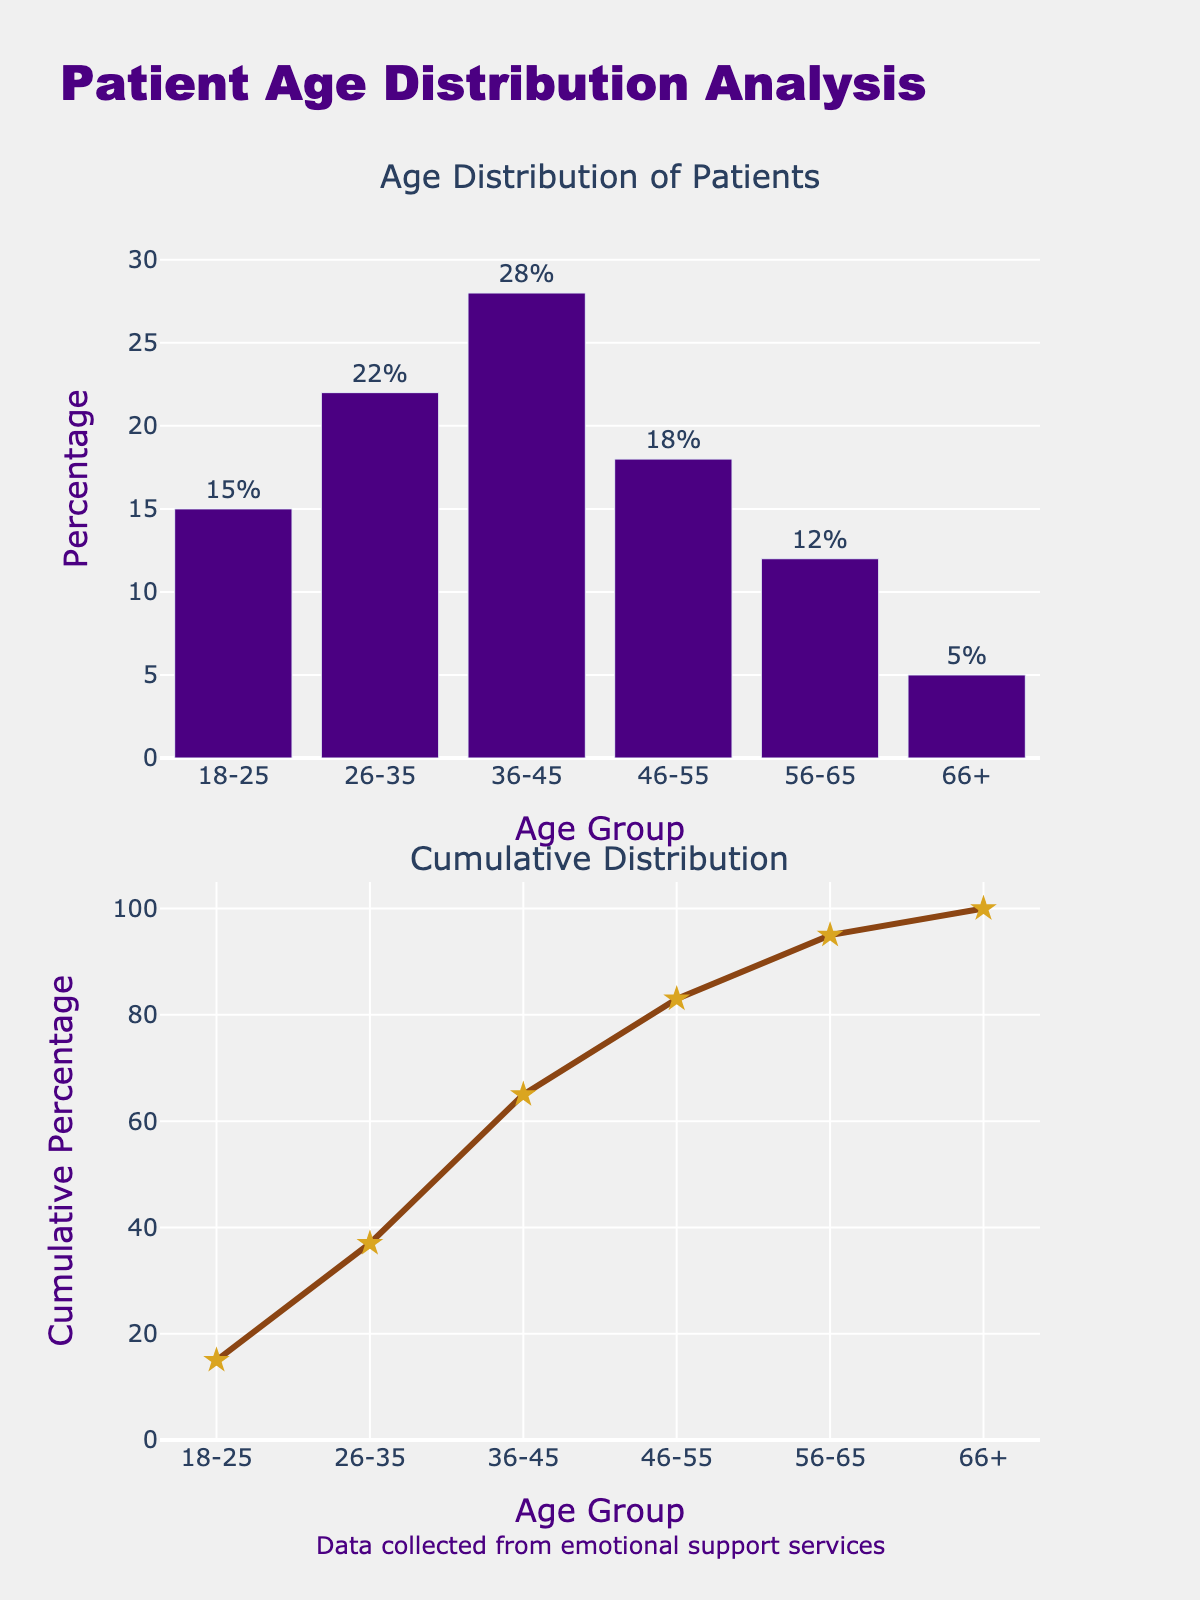What is the title of the figure? The title is written at the top of the figure. It says "Patient Age Distribution Analysis".
Answer: "Patient Age Distribution Analysis" Which age group has the highest percentage of patients? In the first subplot, the bar representing the age group 36-45 is the tallest, indicating it has the highest percentage.
Answer: 36-45 What is the cumulative percentage at the age group 56-65? In the second subplot, follow the line chart to the age group labeled 56-65. The text above the marker reads 95%, which is the cumulative percentage.
Answer: 95% How many age groups are represented in the bar chart? Count the distinct bars in the first subplot. There are six bars, each representing a different age group.
Answer: Six What is the percentage of patients in the age group 26-35? Look at the bar in the first subplot labeled 26-35. The bar's text shows 22%, which represents the percentage.
Answer: 22% By how much does the percentage of the 36-45 age group exceed that of the 18-25 age group? The percentage of the 36-45 age group is 28%, and for the 18-25 age group, it is 15%. Subtracting these gives 28% - 15% = 13%.
Answer: 13% Which age groups together account for over 50% of the patients? Tally the percentages from the first subplot: 18-25 (15%), 26-35 (22%), and 36-45 (28%). These add up to 15% + 22% + 28% = 65%, which is over 50%. Thus, these three groups together account for over 50%.
Answer: 18-25, 26-35, and 36-45 Does the cumulative percentage ever decrease across the age groups? By definition, a cumulative percentage never decreases; it either increases or stays the same. Following the line chart in the second subplot, it only rises as you move across the age groups.
Answer: No What is the cumulative percentage up to the 46-55 age group? In the second subplot, the line chart shows the cumulative percentage up to 46-55. The text above the marker reads 83%.
Answer: 83% How does the percentage of patients in the 56-65 age group compare to the 66+ age group? The bar for 56-65 in the first subplot shows 12%, while the bar for 66+ shows 5%. Since 12% is greater than 5%, the 56-65 age group has a higher percentage.
Answer: 56-65 is higher 